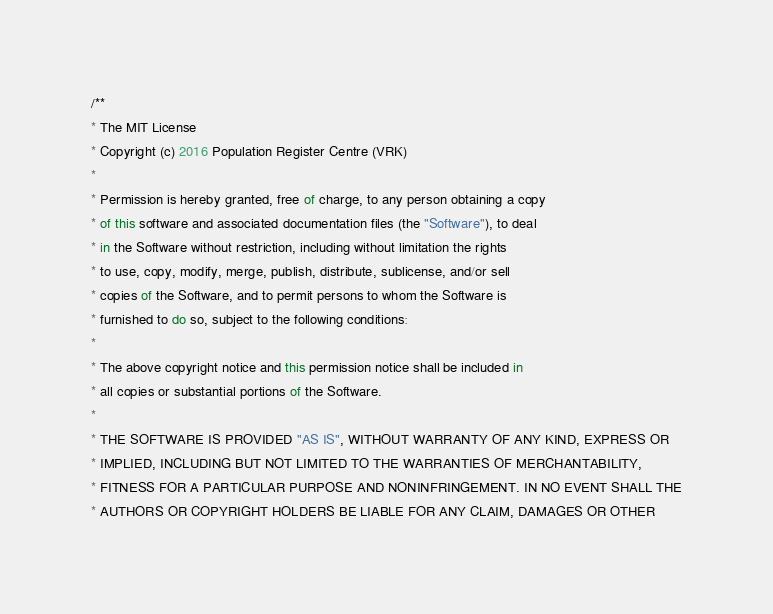Convert code to text. <code><loc_0><loc_0><loc_500><loc_500><_JavaScript_>/**
* The MIT License
* Copyright (c) 2016 Population Register Centre (VRK)
*
* Permission is hereby granted, free of charge, to any person obtaining a copy
* of this software and associated documentation files (the "Software"), to deal
* in the Software without restriction, including without limitation the rights
* to use, copy, modify, merge, publish, distribute, sublicense, and/or sell
* copies of the Software, and to permit persons to whom the Software is
* furnished to do so, subject to the following conditions:
*
* The above copyright notice and this permission notice shall be included in
* all copies or substantial portions of the Software.
*
* THE SOFTWARE IS PROVIDED "AS IS", WITHOUT WARRANTY OF ANY KIND, EXPRESS OR
* IMPLIED, INCLUDING BUT NOT LIMITED TO THE WARRANTIES OF MERCHANTABILITY,
* FITNESS FOR A PARTICULAR PURPOSE AND NONINFRINGEMENT. IN NO EVENT SHALL THE
* AUTHORS OR COPYRIGHT HOLDERS BE LIABLE FOR ANY CLAIM, DAMAGES OR OTHER</code> 